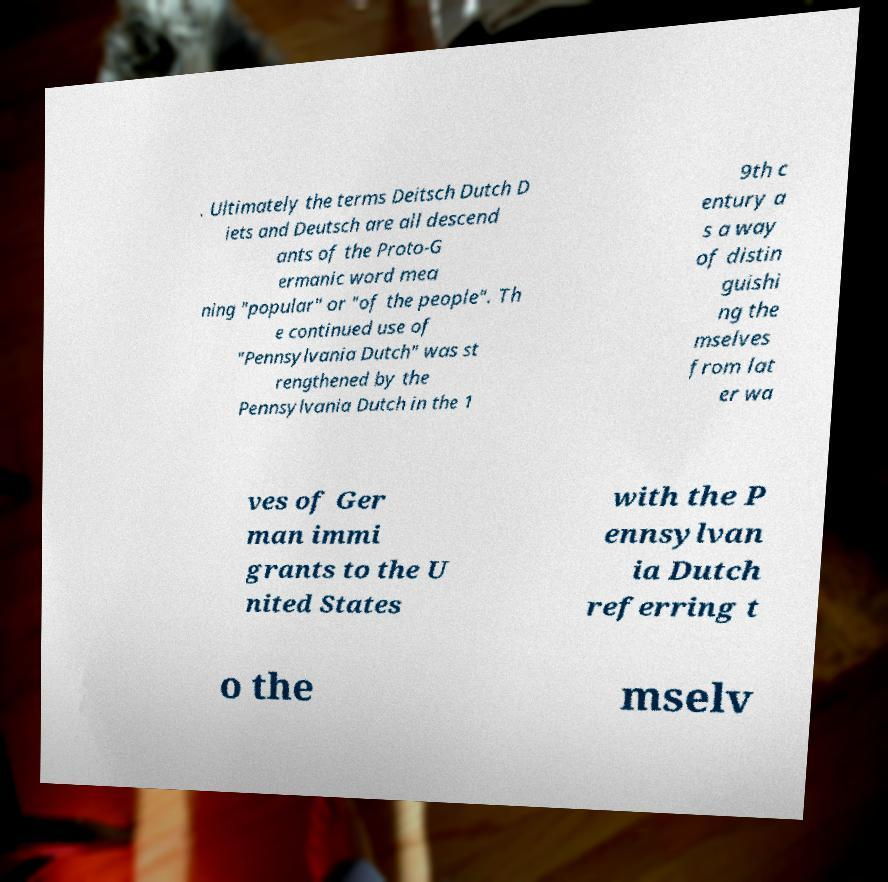Can you accurately transcribe the text from the provided image for me? . Ultimately the terms Deitsch Dutch D iets and Deutsch are all descend ants of the Proto-G ermanic word mea ning "popular" or "of the people". Th e continued use of "Pennsylvania Dutch" was st rengthened by the Pennsylvania Dutch in the 1 9th c entury a s a way of distin guishi ng the mselves from lat er wa ves of Ger man immi grants to the U nited States with the P ennsylvan ia Dutch referring t o the mselv 